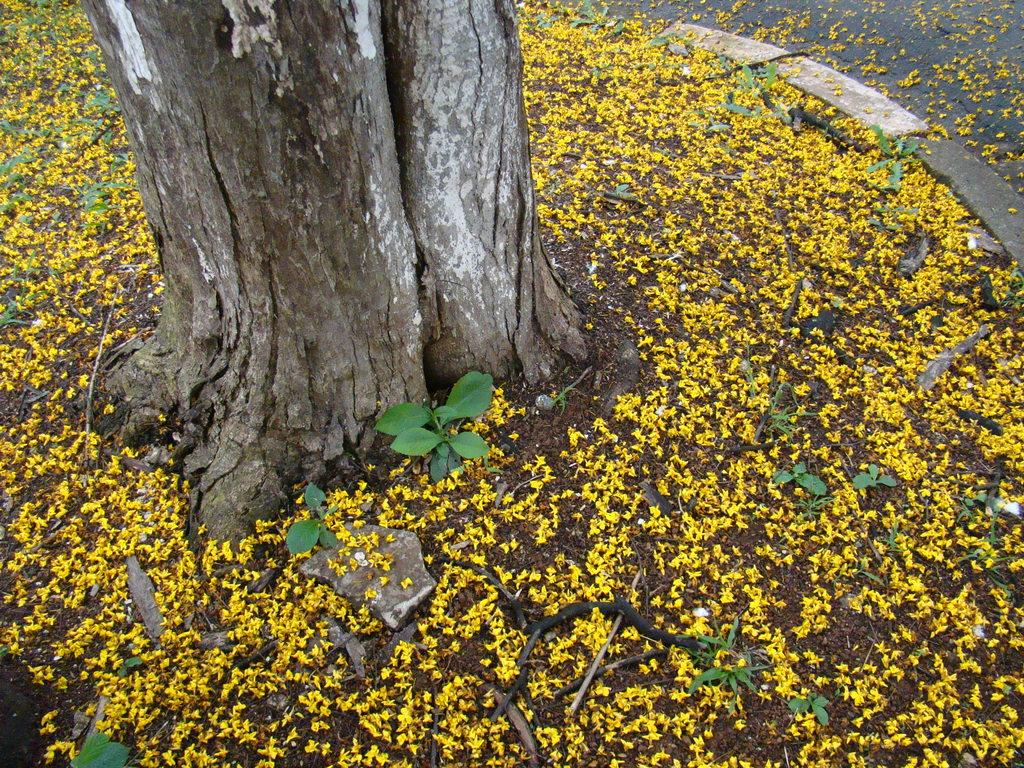What object is located at the top side of the image? There is a trunk at the top side of the image. What can be found on the floor in the image? There are sticks and flowers on the floor. What is the color of the flowers on the floor? The flowers on the floor are yellow in color. What type of current can be seen flowing through the sink in the image? There is no sink present in the image, so it is not possible to determine if there is any current flowing through it. 